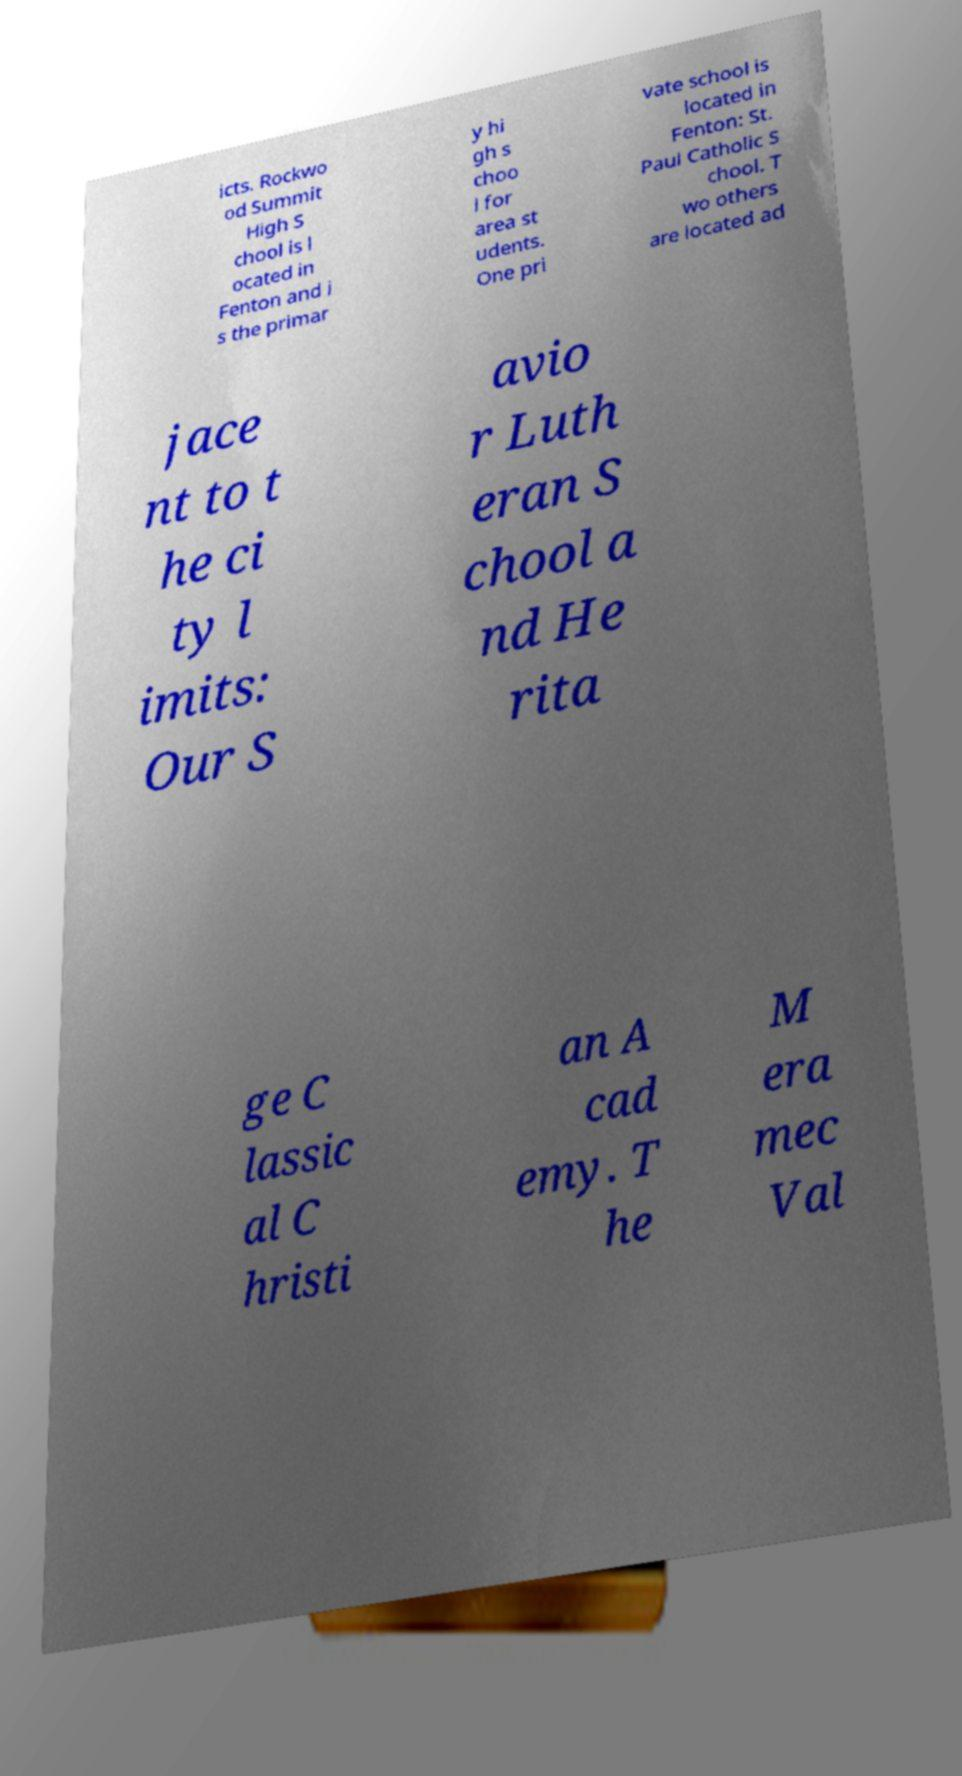Can you read and provide the text displayed in the image?This photo seems to have some interesting text. Can you extract and type it out for me? icts. Rockwo od Summit High S chool is l ocated in Fenton and i s the primar y hi gh s choo l for area st udents. One pri vate school is located in Fenton: St. Paul Catholic S chool. T wo others are located ad jace nt to t he ci ty l imits: Our S avio r Luth eran S chool a nd He rita ge C lassic al C hristi an A cad emy. T he M era mec Val 